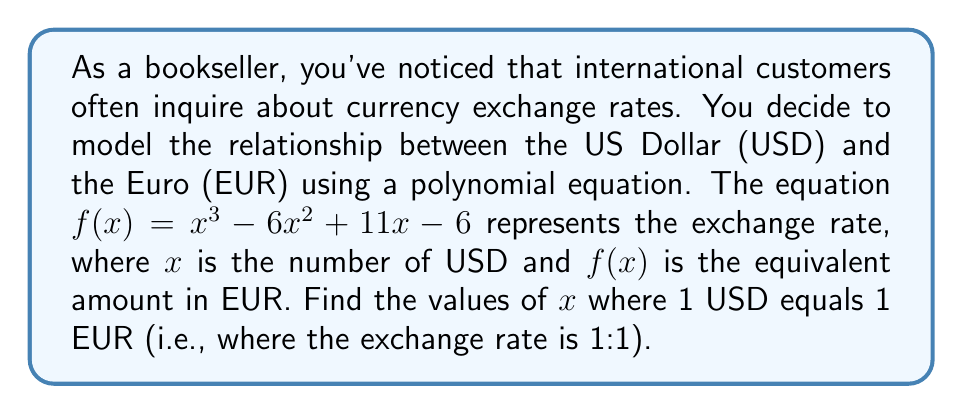Help me with this question. To solve this problem, we need to find the roots of the equation $f(x) - x = 0$, which represents the points where the exchange rate is 1:1.

Step 1: Set up the equation
$$x^3 - 6x^2 + 11x - 6 - x = 0$$

Step 2: Simplify
$$x^3 - 6x^2 + 10x - 6 = 0$$

Step 3: Factor the polynomial
We can see that this is a cubic equation. Let's try to guess one factor first. We can see that $x = 1$ is a solution (1³ - 6(1)² + 10(1) - 6 = 0). So $(x - 1)$ is a factor.

Now we can divide the polynomial by $(x - 1)$ to get the other factor:

$$(x^3 - 6x^2 + 10x - 6) ÷ (x - 1) = x^2 - 5x + 6$$

So our factored equation is:
$$(x - 1)(x^2 - 5x + 6) = 0$$

Step 4: Solve the quadratic factor
For the quadratic factor $x^2 - 5x + 6 = 0$, we can use the quadratic formula:

$$x = \frac{-b \pm \sqrt{b^2 - 4ac}}{2a}$$

Where $a = 1$, $b = -5$, and $c = 6$

$$x = \frac{5 \pm \sqrt{25 - 24}}{2} = \frac{5 \pm 1}{2}$$

This gives us $x = 3$ or $x = 2$

Step 5: Combine all solutions
Our solutions are $x = 1$, $x = 2$, and $x = 3$
Answer: The exchange rate between USD and EUR is 1:1 when $x = 1$, $x = 2$, or $x = 3$. 